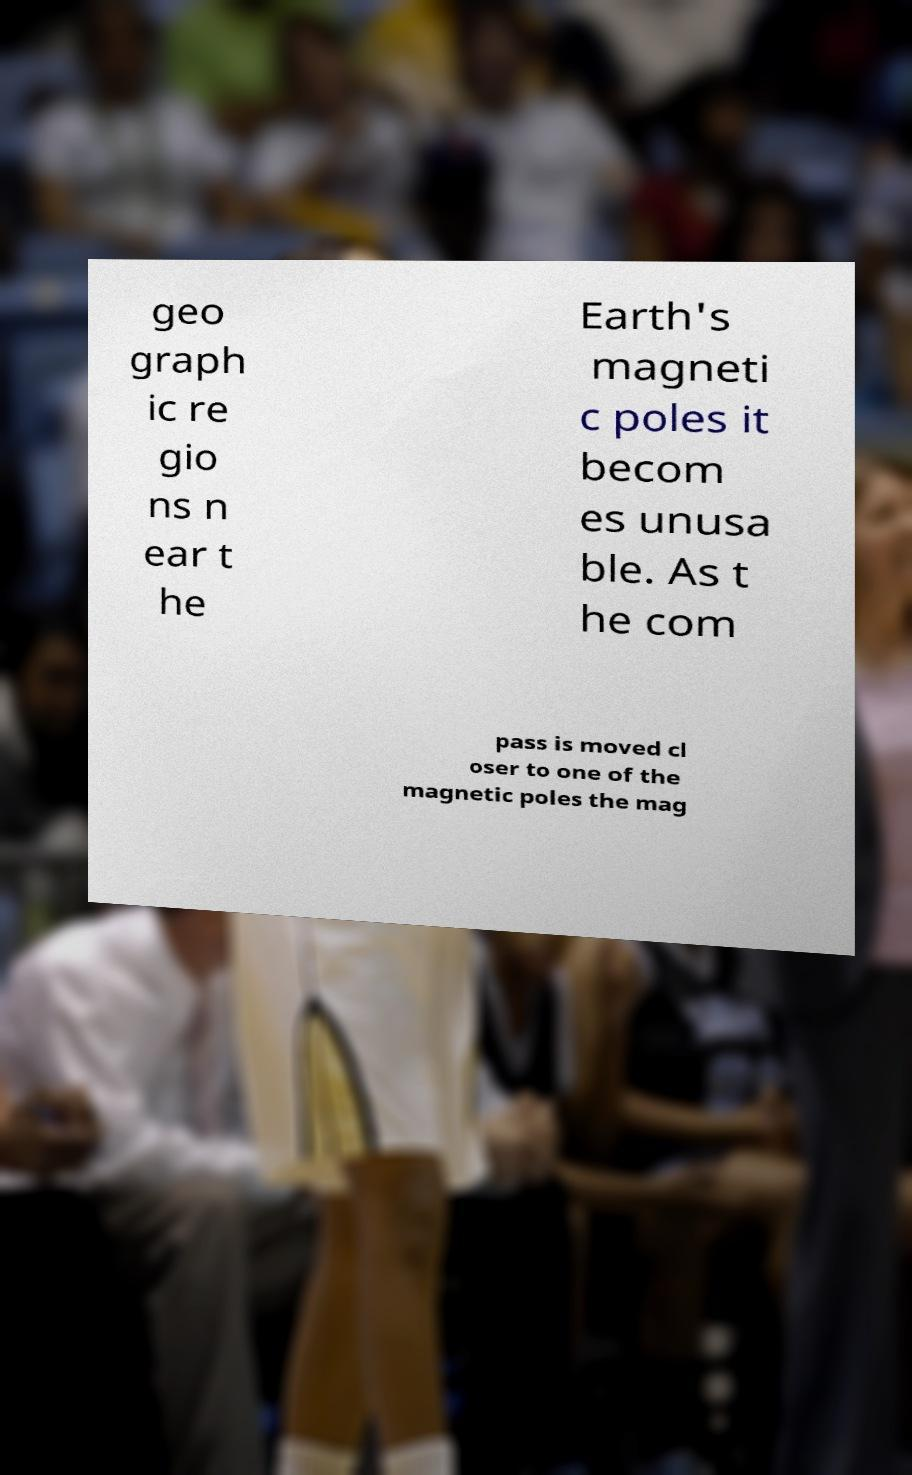Please identify and transcribe the text found in this image. geo graph ic re gio ns n ear t he Earth's magneti c poles it becom es unusa ble. As t he com pass is moved cl oser to one of the magnetic poles the mag 